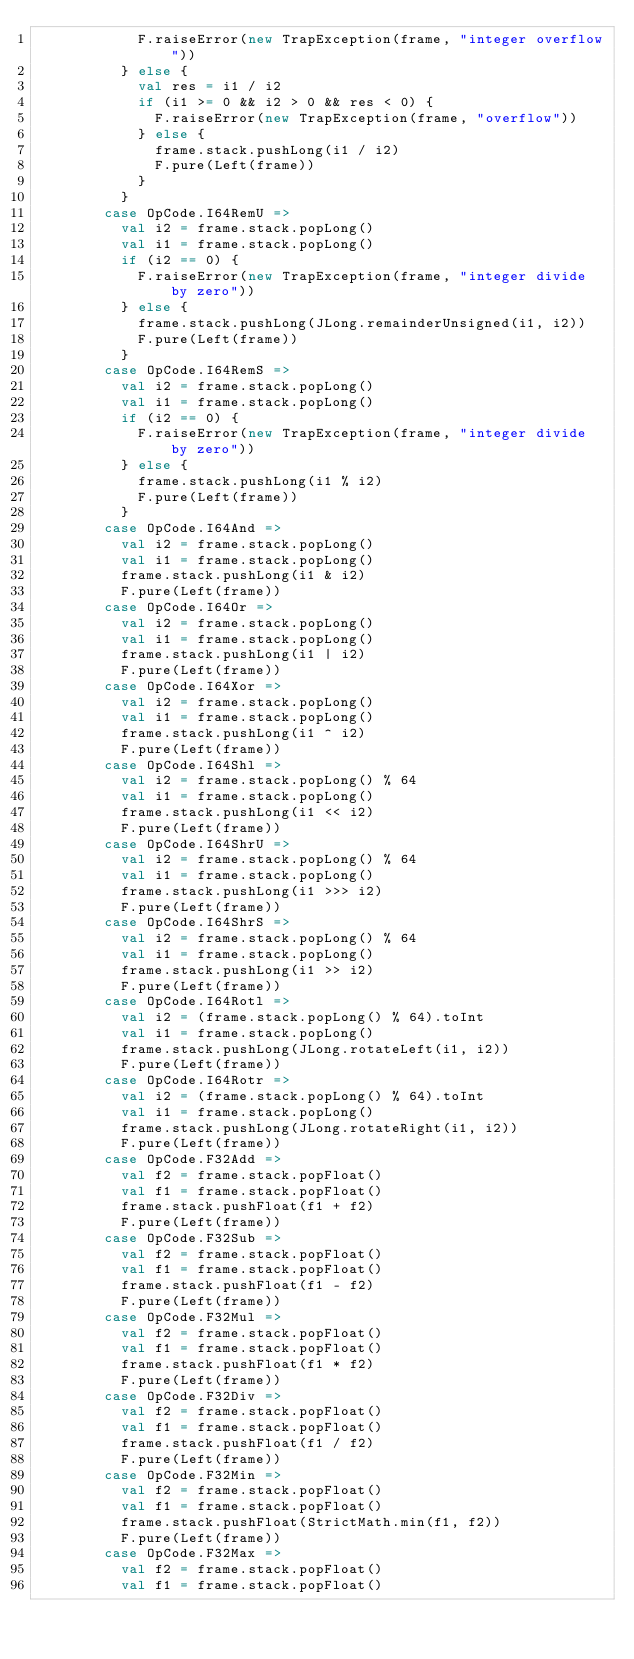<code> <loc_0><loc_0><loc_500><loc_500><_Scala_>            F.raiseError(new TrapException(frame, "integer overflow"))
          } else {
            val res = i1 / i2
            if (i1 >= 0 && i2 > 0 && res < 0) {
              F.raiseError(new TrapException(frame, "overflow"))
            } else {
              frame.stack.pushLong(i1 / i2)
              F.pure(Left(frame))
            }
          }
        case OpCode.I64RemU =>
          val i2 = frame.stack.popLong()
          val i1 = frame.stack.popLong()
          if (i2 == 0) {
            F.raiseError(new TrapException(frame, "integer divide by zero"))
          } else {
            frame.stack.pushLong(JLong.remainderUnsigned(i1, i2))
            F.pure(Left(frame))
          }
        case OpCode.I64RemS =>
          val i2 = frame.stack.popLong()
          val i1 = frame.stack.popLong()
          if (i2 == 0) {
            F.raiseError(new TrapException(frame, "integer divide by zero"))
          } else {
            frame.stack.pushLong(i1 % i2)
            F.pure(Left(frame))
          }
        case OpCode.I64And =>
          val i2 = frame.stack.popLong()
          val i1 = frame.stack.popLong()
          frame.stack.pushLong(i1 & i2)
          F.pure(Left(frame))
        case OpCode.I64Or =>
          val i2 = frame.stack.popLong()
          val i1 = frame.stack.popLong()
          frame.stack.pushLong(i1 | i2)
          F.pure(Left(frame))
        case OpCode.I64Xor =>
          val i2 = frame.stack.popLong()
          val i1 = frame.stack.popLong()
          frame.stack.pushLong(i1 ^ i2)
          F.pure(Left(frame))
        case OpCode.I64Shl =>
          val i2 = frame.stack.popLong() % 64
          val i1 = frame.stack.popLong()
          frame.stack.pushLong(i1 << i2)
          F.pure(Left(frame))
        case OpCode.I64ShrU =>
          val i2 = frame.stack.popLong() % 64
          val i1 = frame.stack.popLong()
          frame.stack.pushLong(i1 >>> i2)
          F.pure(Left(frame))
        case OpCode.I64ShrS =>
          val i2 = frame.stack.popLong() % 64
          val i1 = frame.stack.popLong()
          frame.stack.pushLong(i1 >> i2)
          F.pure(Left(frame))
        case OpCode.I64Rotl =>
          val i2 = (frame.stack.popLong() % 64).toInt
          val i1 = frame.stack.popLong()
          frame.stack.pushLong(JLong.rotateLeft(i1, i2))
          F.pure(Left(frame))
        case OpCode.I64Rotr =>
          val i2 = (frame.stack.popLong() % 64).toInt
          val i1 = frame.stack.popLong()
          frame.stack.pushLong(JLong.rotateRight(i1, i2))
          F.pure(Left(frame))
        case OpCode.F32Add =>
          val f2 = frame.stack.popFloat()
          val f1 = frame.stack.popFloat()
          frame.stack.pushFloat(f1 + f2)
          F.pure(Left(frame))
        case OpCode.F32Sub =>
          val f2 = frame.stack.popFloat()
          val f1 = frame.stack.popFloat()
          frame.stack.pushFloat(f1 - f2)
          F.pure(Left(frame))
        case OpCode.F32Mul =>
          val f2 = frame.stack.popFloat()
          val f1 = frame.stack.popFloat()
          frame.stack.pushFloat(f1 * f2)
          F.pure(Left(frame))
        case OpCode.F32Div =>
          val f2 = frame.stack.popFloat()
          val f1 = frame.stack.popFloat()
          frame.stack.pushFloat(f1 / f2)
          F.pure(Left(frame))
        case OpCode.F32Min =>
          val f2 = frame.stack.popFloat()
          val f1 = frame.stack.popFloat()
          frame.stack.pushFloat(StrictMath.min(f1, f2))
          F.pure(Left(frame))
        case OpCode.F32Max =>
          val f2 = frame.stack.popFloat()
          val f1 = frame.stack.popFloat()</code> 